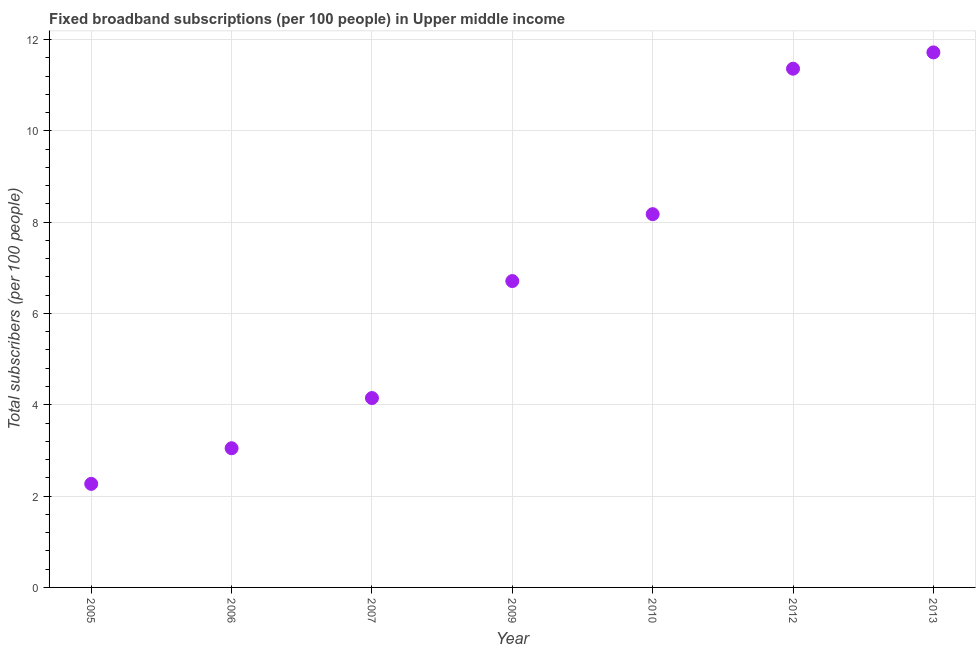What is the total number of fixed broadband subscriptions in 2009?
Offer a terse response. 6.71. Across all years, what is the maximum total number of fixed broadband subscriptions?
Keep it short and to the point. 11.72. Across all years, what is the minimum total number of fixed broadband subscriptions?
Offer a terse response. 2.27. In which year was the total number of fixed broadband subscriptions minimum?
Your response must be concise. 2005. What is the sum of the total number of fixed broadband subscriptions?
Your answer should be very brief. 47.43. What is the difference between the total number of fixed broadband subscriptions in 2006 and 2010?
Give a very brief answer. -5.13. What is the average total number of fixed broadband subscriptions per year?
Give a very brief answer. 6.78. What is the median total number of fixed broadband subscriptions?
Provide a succinct answer. 6.71. Do a majority of the years between 2009 and 2007 (inclusive) have total number of fixed broadband subscriptions greater than 10.8 ?
Give a very brief answer. No. What is the ratio of the total number of fixed broadband subscriptions in 2005 to that in 2006?
Provide a succinct answer. 0.74. Is the total number of fixed broadband subscriptions in 2005 less than that in 2007?
Provide a succinct answer. Yes. What is the difference between the highest and the second highest total number of fixed broadband subscriptions?
Provide a short and direct response. 0.36. What is the difference between the highest and the lowest total number of fixed broadband subscriptions?
Give a very brief answer. 9.45. In how many years, is the total number of fixed broadband subscriptions greater than the average total number of fixed broadband subscriptions taken over all years?
Offer a terse response. 3. How many dotlines are there?
Ensure brevity in your answer.  1. Are the values on the major ticks of Y-axis written in scientific E-notation?
Make the answer very short. No. Does the graph contain any zero values?
Give a very brief answer. No. What is the title of the graph?
Keep it short and to the point. Fixed broadband subscriptions (per 100 people) in Upper middle income. What is the label or title of the X-axis?
Give a very brief answer. Year. What is the label or title of the Y-axis?
Offer a terse response. Total subscribers (per 100 people). What is the Total subscribers (per 100 people) in 2005?
Give a very brief answer. 2.27. What is the Total subscribers (per 100 people) in 2006?
Keep it short and to the point. 3.05. What is the Total subscribers (per 100 people) in 2007?
Offer a very short reply. 4.15. What is the Total subscribers (per 100 people) in 2009?
Your response must be concise. 6.71. What is the Total subscribers (per 100 people) in 2010?
Your answer should be very brief. 8.17. What is the Total subscribers (per 100 people) in 2012?
Offer a terse response. 11.36. What is the Total subscribers (per 100 people) in 2013?
Provide a short and direct response. 11.72. What is the difference between the Total subscribers (per 100 people) in 2005 and 2006?
Make the answer very short. -0.78. What is the difference between the Total subscribers (per 100 people) in 2005 and 2007?
Provide a short and direct response. -1.88. What is the difference between the Total subscribers (per 100 people) in 2005 and 2009?
Offer a terse response. -4.44. What is the difference between the Total subscribers (per 100 people) in 2005 and 2010?
Give a very brief answer. -5.91. What is the difference between the Total subscribers (per 100 people) in 2005 and 2012?
Your answer should be very brief. -9.09. What is the difference between the Total subscribers (per 100 people) in 2005 and 2013?
Keep it short and to the point. -9.45. What is the difference between the Total subscribers (per 100 people) in 2006 and 2007?
Provide a succinct answer. -1.1. What is the difference between the Total subscribers (per 100 people) in 2006 and 2009?
Offer a terse response. -3.66. What is the difference between the Total subscribers (per 100 people) in 2006 and 2010?
Give a very brief answer. -5.13. What is the difference between the Total subscribers (per 100 people) in 2006 and 2012?
Your answer should be very brief. -8.31. What is the difference between the Total subscribers (per 100 people) in 2006 and 2013?
Your answer should be very brief. -8.67. What is the difference between the Total subscribers (per 100 people) in 2007 and 2009?
Make the answer very short. -2.56. What is the difference between the Total subscribers (per 100 people) in 2007 and 2010?
Your response must be concise. -4.03. What is the difference between the Total subscribers (per 100 people) in 2007 and 2012?
Your response must be concise. -7.21. What is the difference between the Total subscribers (per 100 people) in 2007 and 2013?
Your answer should be very brief. -7.57. What is the difference between the Total subscribers (per 100 people) in 2009 and 2010?
Keep it short and to the point. -1.47. What is the difference between the Total subscribers (per 100 people) in 2009 and 2012?
Keep it short and to the point. -4.65. What is the difference between the Total subscribers (per 100 people) in 2009 and 2013?
Your answer should be very brief. -5.01. What is the difference between the Total subscribers (per 100 people) in 2010 and 2012?
Make the answer very short. -3.19. What is the difference between the Total subscribers (per 100 people) in 2010 and 2013?
Provide a succinct answer. -3.54. What is the difference between the Total subscribers (per 100 people) in 2012 and 2013?
Keep it short and to the point. -0.36. What is the ratio of the Total subscribers (per 100 people) in 2005 to that in 2006?
Provide a succinct answer. 0.74. What is the ratio of the Total subscribers (per 100 people) in 2005 to that in 2007?
Offer a terse response. 0.55. What is the ratio of the Total subscribers (per 100 people) in 2005 to that in 2009?
Your answer should be very brief. 0.34. What is the ratio of the Total subscribers (per 100 people) in 2005 to that in 2010?
Provide a short and direct response. 0.28. What is the ratio of the Total subscribers (per 100 people) in 2005 to that in 2013?
Your answer should be very brief. 0.19. What is the ratio of the Total subscribers (per 100 people) in 2006 to that in 2007?
Offer a terse response. 0.73. What is the ratio of the Total subscribers (per 100 people) in 2006 to that in 2009?
Your response must be concise. 0.45. What is the ratio of the Total subscribers (per 100 people) in 2006 to that in 2010?
Provide a short and direct response. 0.37. What is the ratio of the Total subscribers (per 100 people) in 2006 to that in 2012?
Provide a succinct answer. 0.27. What is the ratio of the Total subscribers (per 100 people) in 2006 to that in 2013?
Make the answer very short. 0.26. What is the ratio of the Total subscribers (per 100 people) in 2007 to that in 2009?
Your answer should be very brief. 0.62. What is the ratio of the Total subscribers (per 100 people) in 2007 to that in 2010?
Provide a short and direct response. 0.51. What is the ratio of the Total subscribers (per 100 people) in 2007 to that in 2012?
Keep it short and to the point. 0.36. What is the ratio of the Total subscribers (per 100 people) in 2007 to that in 2013?
Your response must be concise. 0.35. What is the ratio of the Total subscribers (per 100 people) in 2009 to that in 2010?
Provide a succinct answer. 0.82. What is the ratio of the Total subscribers (per 100 people) in 2009 to that in 2012?
Give a very brief answer. 0.59. What is the ratio of the Total subscribers (per 100 people) in 2009 to that in 2013?
Your answer should be compact. 0.57. What is the ratio of the Total subscribers (per 100 people) in 2010 to that in 2012?
Your answer should be compact. 0.72. What is the ratio of the Total subscribers (per 100 people) in 2010 to that in 2013?
Make the answer very short. 0.7. 